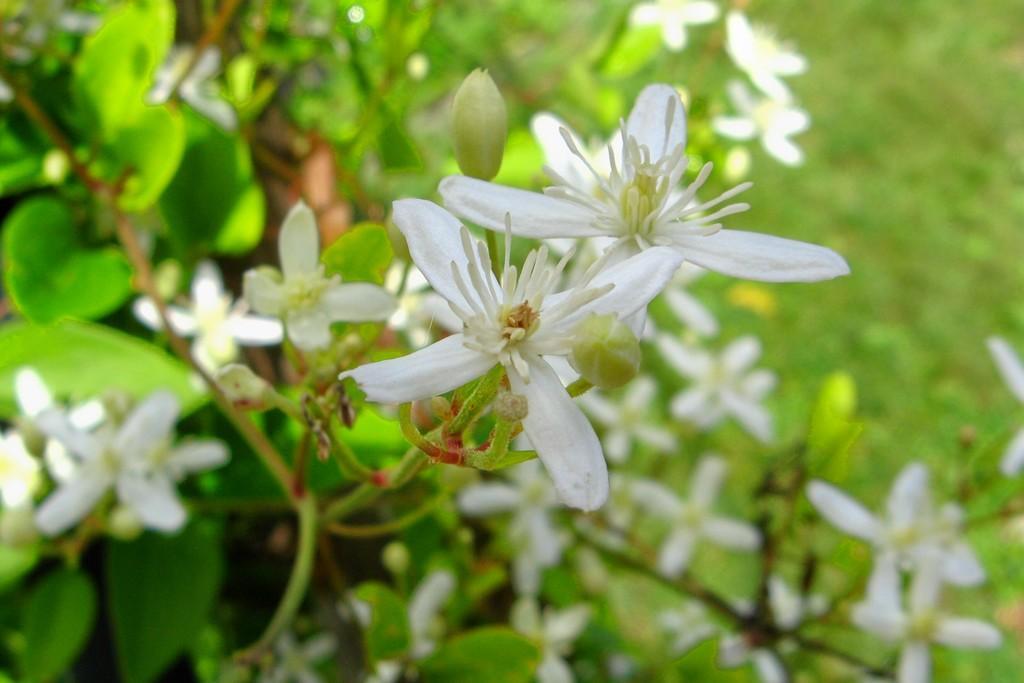Can you describe this image briefly? In this picture we can see there are plants with flowers. Behind the plants, there is the blurred background. 